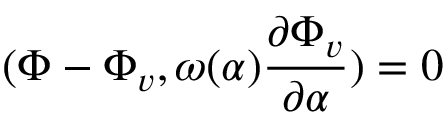<formula> <loc_0><loc_0><loc_500><loc_500>( \Phi - \Phi _ { v } , \omega ( \alpha ) { \frac { \partial \Phi _ { v } } { \partial \alpha } } ) = 0</formula> 